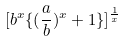<formula> <loc_0><loc_0><loc_500><loc_500>[ b ^ { x } \{ ( \frac { a } { b } ) ^ { x } + 1 \} ] ^ { \frac { 1 } { x } }</formula> 